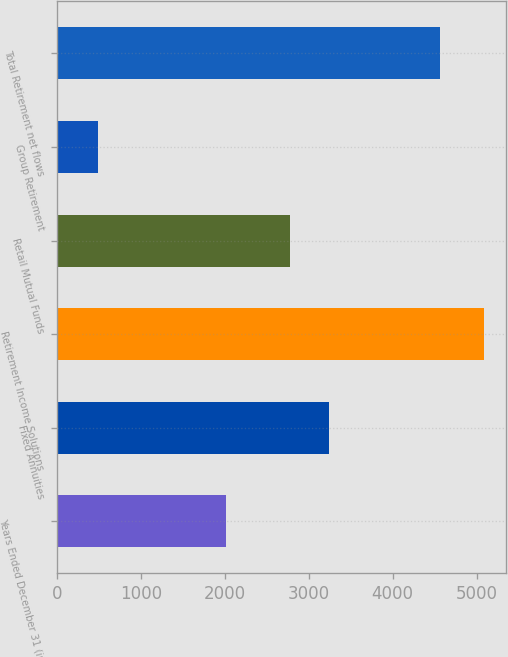Convert chart to OTSL. <chart><loc_0><loc_0><loc_500><loc_500><bar_chart><fcel>Years Ended December 31 (in<fcel>Fixed Annuities<fcel>Retirement Income Solutions<fcel>Retail Mutual Funds<fcel>Group Retirement<fcel>Total Retirement net flows<nl><fcel>2013<fcel>3240<fcel>5092<fcel>2780<fcel>492<fcel>4560<nl></chart> 